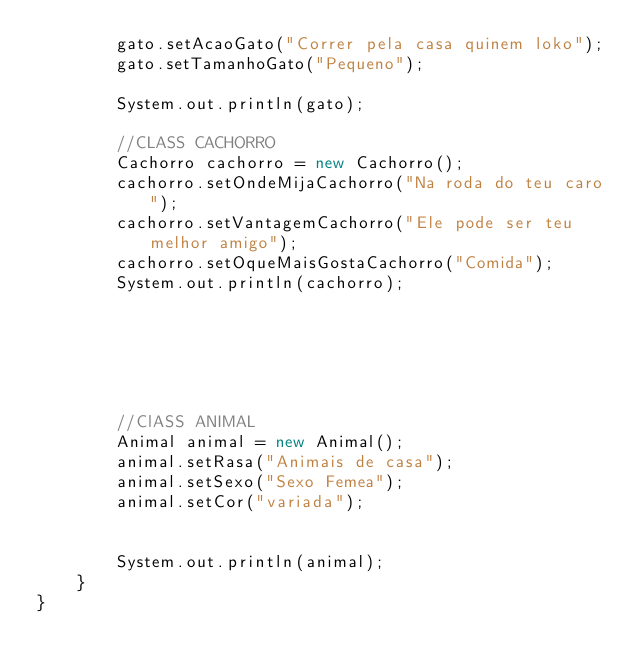Convert code to text. <code><loc_0><loc_0><loc_500><loc_500><_Java_>        gato.setAcaoGato("Correr pela casa quinem loko");
        gato.setTamanhoGato("Pequeno");
       
        System.out.println(gato);
        
        //CLASS CACHORRO
        Cachorro cachorro = new Cachorro();
        cachorro.setOndeMijaCachorro("Na roda do teu caro");
        cachorro.setVantagemCachorro("Ele pode ser teu melhor amigo");
        cachorro.setOqueMaisGostaCachorro("Comida");
        System.out.println(cachorro);
        
     
        
        
        
        
        //ClASS ANIMAL
        Animal animal = new Animal();
        animal.setRasa("Animais de casa");
        animal.setSexo("Sexo Femea");
        animal.setCor("variada");
        
        
        System.out.println(animal);
    }
}</code> 